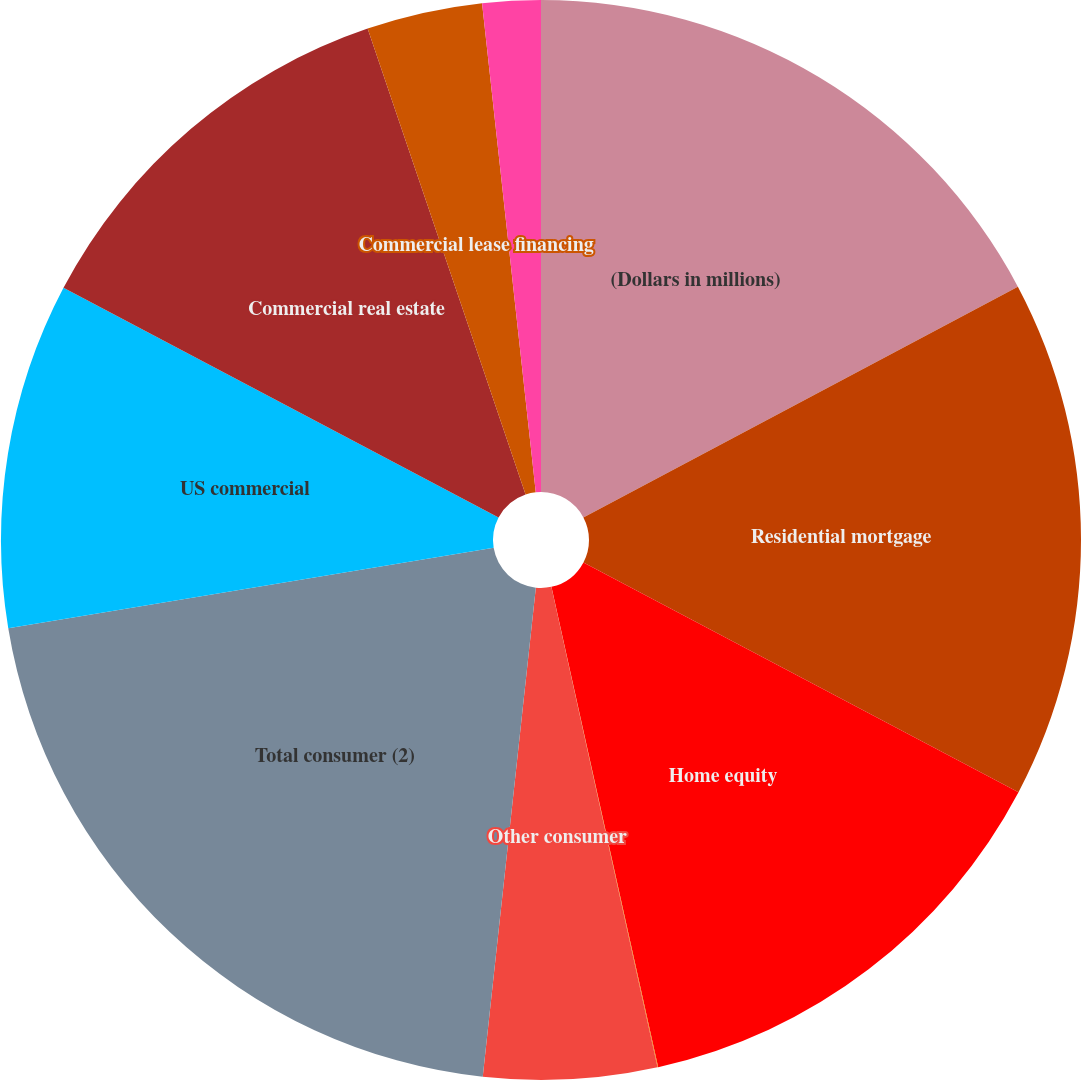<chart> <loc_0><loc_0><loc_500><loc_500><pie_chart><fcel>(Dollars in millions)<fcel>Residential mortgage<fcel>Home equity<fcel>Direct/Indirect consumer<fcel>Other consumer<fcel>Total consumer (2)<fcel>US commercial<fcel>Commercial real estate<fcel>Commercial lease financing<fcel>Non-US commercial<nl><fcel>17.22%<fcel>15.5%<fcel>13.78%<fcel>0.02%<fcel>5.18%<fcel>20.66%<fcel>10.34%<fcel>12.06%<fcel>3.46%<fcel>1.74%<nl></chart> 